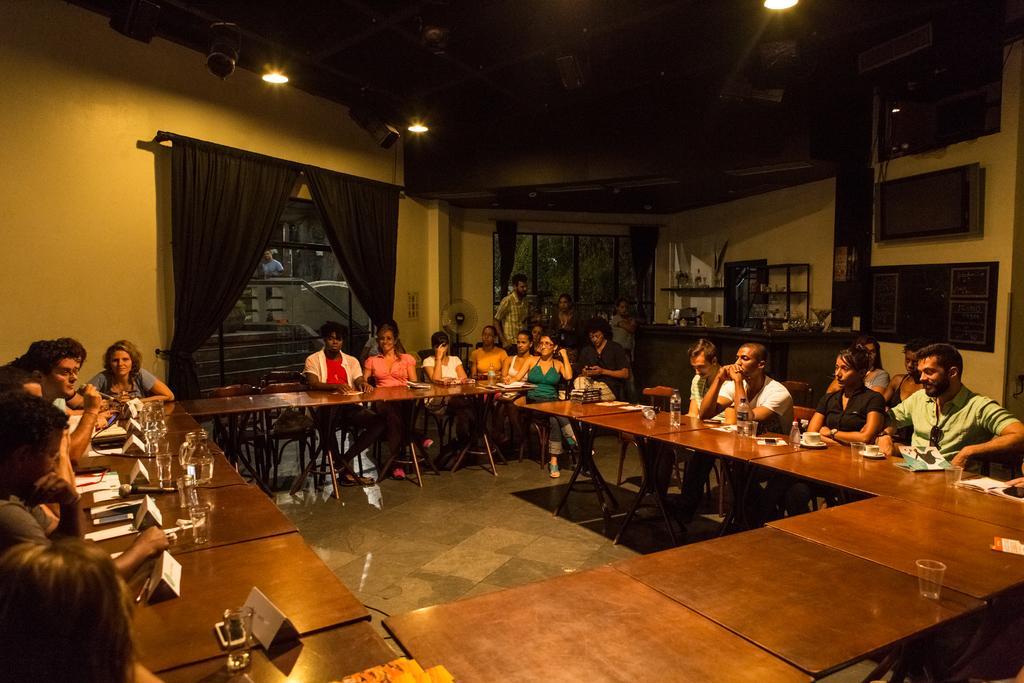Describe this image in one or two sentences. The image is clicked in a room, the tables are arranged in O shape and people are sitting around that table. On the table there are glasses, bottles, boards etc. In the background there is a window, through the window there is a staircase. Towards the right corner there is a television besides it there is a desk. 